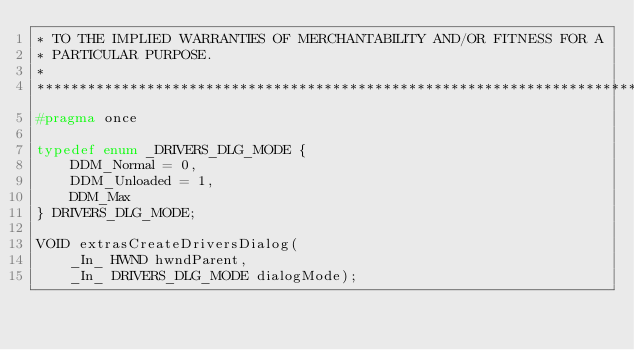Convert code to text. <code><loc_0><loc_0><loc_500><loc_500><_C_>* TO THE IMPLIED WARRANTIES OF MERCHANTABILITY AND/OR FITNESS FOR A
* PARTICULAR PURPOSE.
*
*******************************************************************************/
#pragma once

typedef enum _DRIVERS_DLG_MODE {
    DDM_Normal = 0,
    DDM_Unloaded = 1,
    DDM_Max
} DRIVERS_DLG_MODE;

VOID extrasCreateDriversDialog(
    _In_ HWND hwndParent,
    _In_ DRIVERS_DLG_MODE dialogMode);
</code> 